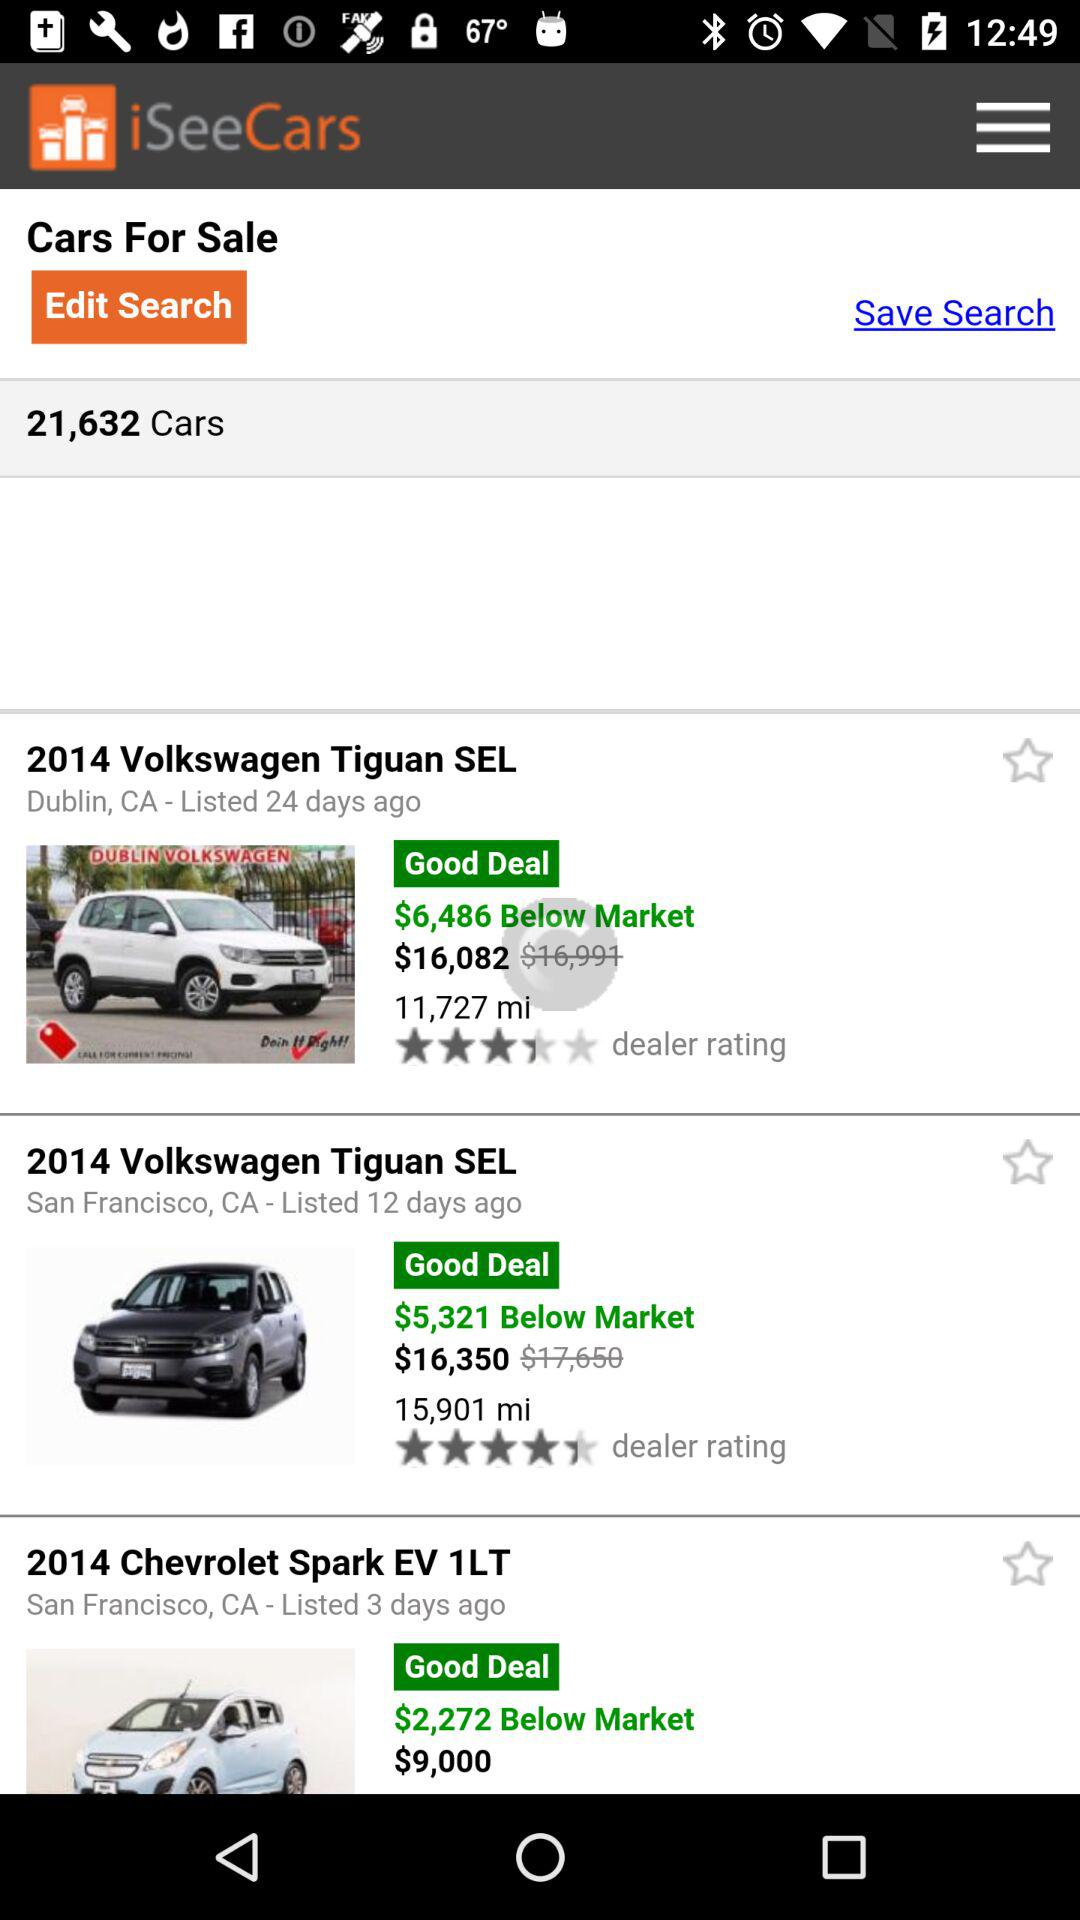Which dealer has a rating of 4.5?
When the provided information is insufficient, respond with <no answer>. <no answer> 